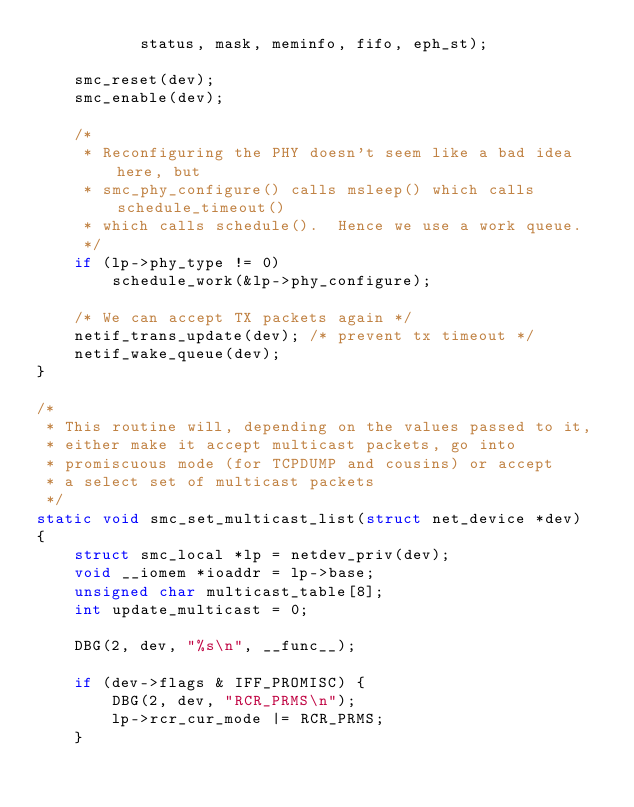<code> <loc_0><loc_0><loc_500><loc_500><_C_>	       status, mask, meminfo, fifo, eph_st);

	smc_reset(dev);
	smc_enable(dev);

	/*
	 * Reconfiguring the PHY doesn't seem like a bad idea here, but
	 * smc_phy_configure() calls msleep() which calls schedule_timeout()
	 * which calls schedule().  Hence we use a work queue.
	 */
	if (lp->phy_type != 0)
		schedule_work(&lp->phy_configure);

	/* We can accept TX packets again */
	netif_trans_update(dev); /* prevent tx timeout */
	netif_wake_queue(dev);
}

/*
 * This routine will, depending on the values passed to it,
 * either make it accept multicast packets, go into
 * promiscuous mode (for TCPDUMP and cousins) or accept
 * a select set of multicast packets
 */
static void smc_set_multicast_list(struct net_device *dev)
{
	struct smc_local *lp = netdev_priv(dev);
	void __iomem *ioaddr = lp->base;
	unsigned char multicast_table[8];
	int update_multicast = 0;

	DBG(2, dev, "%s\n", __func__);

	if (dev->flags & IFF_PROMISC) {
		DBG(2, dev, "RCR_PRMS\n");
		lp->rcr_cur_mode |= RCR_PRMS;
	}
</code> 